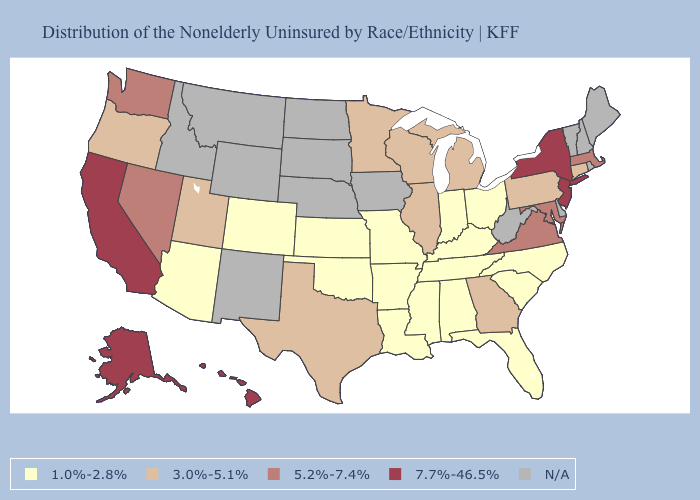Among the states that border Wyoming , does Colorado have the lowest value?
Be succinct. Yes. Which states hav the highest value in the MidWest?
Give a very brief answer. Illinois, Michigan, Minnesota, Wisconsin. Name the states that have a value in the range 1.0%-2.8%?
Short answer required. Alabama, Arizona, Arkansas, Colorado, Florida, Indiana, Kansas, Kentucky, Louisiana, Mississippi, Missouri, North Carolina, Ohio, Oklahoma, South Carolina, Tennessee. What is the value of Iowa?
Be succinct. N/A. Which states hav the highest value in the West?
Short answer required. Alaska, California, Hawaii. What is the value of New Jersey?
Give a very brief answer. 7.7%-46.5%. Name the states that have a value in the range 3.0%-5.1%?
Answer briefly. Connecticut, Georgia, Illinois, Michigan, Minnesota, Oregon, Pennsylvania, Texas, Utah, Wisconsin. Does the map have missing data?
Write a very short answer. Yes. Name the states that have a value in the range N/A?
Quick response, please. Delaware, Idaho, Iowa, Maine, Montana, Nebraska, New Hampshire, New Mexico, North Dakota, Rhode Island, South Dakota, Vermont, West Virginia, Wyoming. Among the states that border Utah , does Nevada have the highest value?
Be succinct. Yes. What is the lowest value in the Northeast?
Answer briefly. 3.0%-5.1%. What is the lowest value in the MidWest?
Write a very short answer. 1.0%-2.8%. Does Arkansas have the highest value in the USA?
Keep it brief. No. 